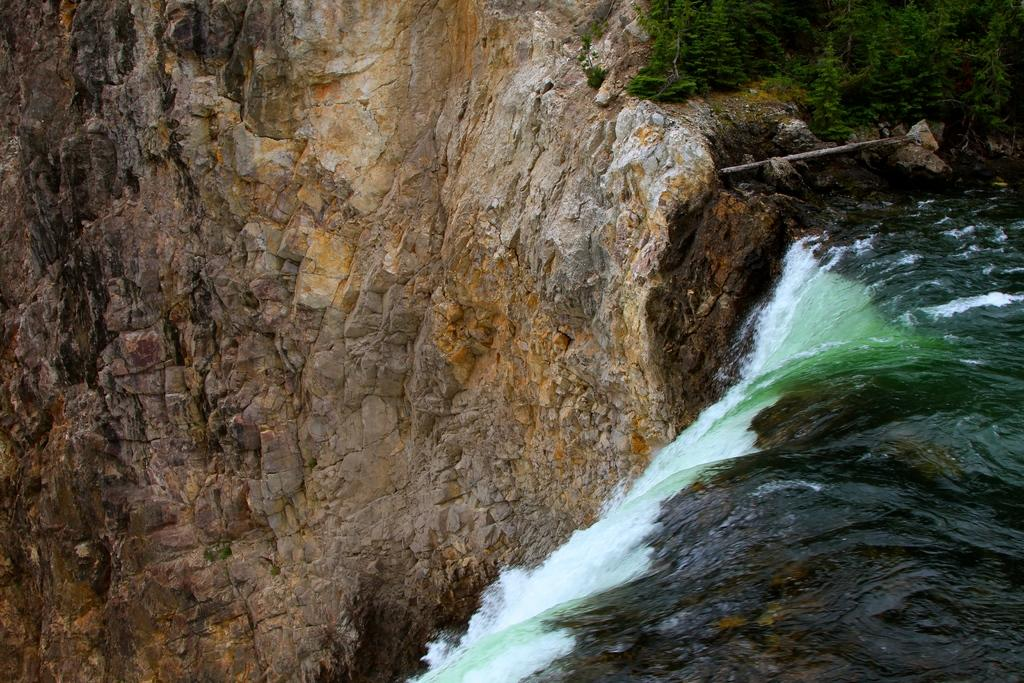What natural feature is located on the right side of the image? There is a waterfall on the right side of the image. What celestial bodies can be seen in the top right corner of the image? Planets are visible in the top right corner of the image. What type of landform is on the left side of the image? There appears to be a rock hill on the left side of the image. What type of substance is being used for the feast in the image? There is no feast present in the image, so no substance is being used for it. Can you see anyone skating in the image? There is no skating activity depicted in the image. 